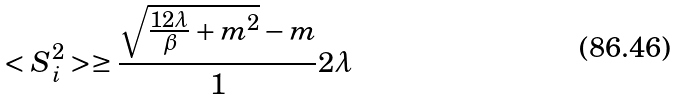Convert formula to latex. <formula><loc_0><loc_0><loc_500><loc_500>< S _ { i } ^ { 2 } > \geq \frac { \sqrt { \frac { 1 2 \lambda } { \beta } + m ^ { 2 } } - m } 1 2 \lambda</formula> 